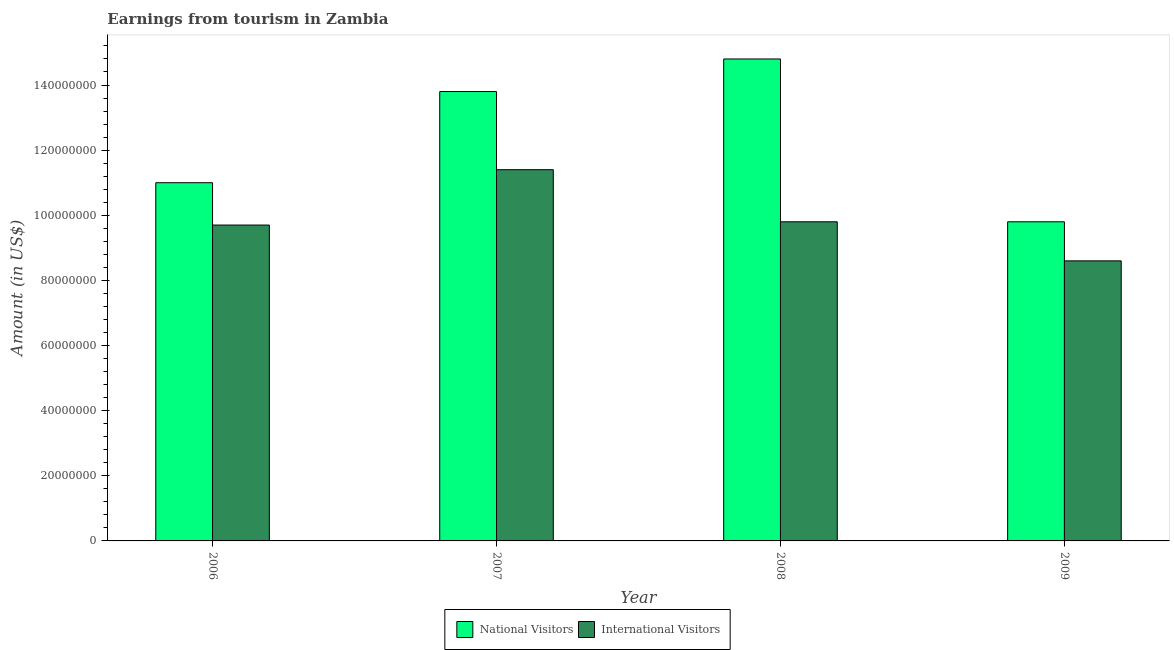How many different coloured bars are there?
Provide a short and direct response. 2. How many groups of bars are there?
Offer a terse response. 4. Are the number of bars on each tick of the X-axis equal?
Give a very brief answer. Yes. What is the amount earned from national visitors in 2008?
Your response must be concise. 1.48e+08. Across all years, what is the maximum amount earned from international visitors?
Ensure brevity in your answer.  1.14e+08. Across all years, what is the minimum amount earned from international visitors?
Your answer should be compact. 8.60e+07. In which year was the amount earned from international visitors maximum?
Your answer should be very brief. 2007. What is the total amount earned from national visitors in the graph?
Your answer should be compact. 4.94e+08. What is the difference between the amount earned from national visitors in 2006 and that in 2008?
Make the answer very short. -3.80e+07. What is the difference between the amount earned from international visitors in 2008 and the amount earned from national visitors in 2009?
Ensure brevity in your answer.  1.20e+07. What is the average amount earned from national visitors per year?
Provide a succinct answer. 1.24e+08. In the year 2008, what is the difference between the amount earned from national visitors and amount earned from international visitors?
Provide a short and direct response. 0. In how many years, is the amount earned from national visitors greater than 80000000 US$?
Your response must be concise. 4. What is the ratio of the amount earned from national visitors in 2006 to that in 2007?
Keep it short and to the point. 0.8. Is the difference between the amount earned from international visitors in 2006 and 2009 greater than the difference between the amount earned from national visitors in 2006 and 2009?
Give a very brief answer. No. What is the difference between the highest and the second highest amount earned from international visitors?
Ensure brevity in your answer.  1.60e+07. What is the difference between the highest and the lowest amount earned from national visitors?
Provide a succinct answer. 5.00e+07. What does the 1st bar from the left in 2008 represents?
Offer a terse response. National Visitors. What does the 1st bar from the right in 2007 represents?
Offer a terse response. International Visitors. Are all the bars in the graph horizontal?
Provide a succinct answer. No. What is the difference between two consecutive major ticks on the Y-axis?
Provide a short and direct response. 2.00e+07. Are the values on the major ticks of Y-axis written in scientific E-notation?
Offer a very short reply. No. Does the graph contain any zero values?
Keep it short and to the point. No. Does the graph contain grids?
Offer a very short reply. No. Where does the legend appear in the graph?
Keep it short and to the point. Bottom center. How are the legend labels stacked?
Make the answer very short. Horizontal. What is the title of the graph?
Offer a very short reply. Earnings from tourism in Zambia. What is the label or title of the Y-axis?
Provide a short and direct response. Amount (in US$). What is the Amount (in US$) in National Visitors in 2006?
Your answer should be very brief. 1.10e+08. What is the Amount (in US$) in International Visitors in 2006?
Offer a very short reply. 9.70e+07. What is the Amount (in US$) in National Visitors in 2007?
Provide a short and direct response. 1.38e+08. What is the Amount (in US$) of International Visitors in 2007?
Offer a very short reply. 1.14e+08. What is the Amount (in US$) in National Visitors in 2008?
Provide a short and direct response. 1.48e+08. What is the Amount (in US$) in International Visitors in 2008?
Ensure brevity in your answer.  9.80e+07. What is the Amount (in US$) in National Visitors in 2009?
Offer a terse response. 9.80e+07. What is the Amount (in US$) of International Visitors in 2009?
Provide a succinct answer. 8.60e+07. Across all years, what is the maximum Amount (in US$) of National Visitors?
Ensure brevity in your answer.  1.48e+08. Across all years, what is the maximum Amount (in US$) of International Visitors?
Provide a succinct answer. 1.14e+08. Across all years, what is the minimum Amount (in US$) in National Visitors?
Keep it short and to the point. 9.80e+07. Across all years, what is the minimum Amount (in US$) of International Visitors?
Provide a short and direct response. 8.60e+07. What is the total Amount (in US$) of National Visitors in the graph?
Provide a short and direct response. 4.94e+08. What is the total Amount (in US$) in International Visitors in the graph?
Your answer should be very brief. 3.95e+08. What is the difference between the Amount (in US$) of National Visitors in 2006 and that in 2007?
Give a very brief answer. -2.80e+07. What is the difference between the Amount (in US$) in International Visitors in 2006 and that in 2007?
Give a very brief answer. -1.70e+07. What is the difference between the Amount (in US$) of National Visitors in 2006 and that in 2008?
Offer a very short reply. -3.80e+07. What is the difference between the Amount (in US$) of National Visitors in 2006 and that in 2009?
Ensure brevity in your answer.  1.20e+07. What is the difference between the Amount (in US$) in International Visitors in 2006 and that in 2009?
Provide a short and direct response. 1.10e+07. What is the difference between the Amount (in US$) in National Visitors in 2007 and that in 2008?
Give a very brief answer. -1.00e+07. What is the difference between the Amount (in US$) in International Visitors in 2007 and that in 2008?
Provide a short and direct response. 1.60e+07. What is the difference between the Amount (in US$) in National Visitors in 2007 and that in 2009?
Make the answer very short. 4.00e+07. What is the difference between the Amount (in US$) of International Visitors in 2007 and that in 2009?
Your answer should be very brief. 2.80e+07. What is the difference between the Amount (in US$) in National Visitors in 2006 and the Amount (in US$) in International Visitors in 2008?
Offer a very short reply. 1.20e+07. What is the difference between the Amount (in US$) in National Visitors in 2006 and the Amount (in US$) in International Visitors in 2009?
Your answer should be very brief. 2.40e+07. What is the difference between the Amount (in US$) of National Visitors in 2007 and the Amount (in US$) of International Visitors in 2008?
Ensure brevity in your answer.  4.00e+07. What is the difference between the Amount (in US$) of National Visitors in 2007 and the Amount (in US$) of International Visitors in 2009?
Offer a very short reply. 5.20e+07. What is the difference between the Amount (in US$) of National Visitors in 2008 and the Amount (in US$) of International Visitors in 2009?
Provide a succinct answer. 6.20e+07. What is the average Amount (in US$) of National Visitors per year?
Offer a terse response. 1.24e+08. What is the average Amount (in US$) in International Visitors per year?
Your answer should be compact. 9.88e+07. In the year 2006, what is the difference between the Amount (in US$) in National Visitors and Amount (in US$) in International Visitors?
Offer a very short reply. 1.30e+07. In the year 2007, what is the difference between the Amount (in US$) in National Visitors and Amount (in US$) in International Visitors?
Keep it short and to the point. 2.40e+07. In the year 2008, what is the difference between the Amount (in US$) in National Visitors and Amount (in US$) in International Visitors?
Offer a very short reply. 5.00e+07. In the year 2009, what is the difference between the Amount (in US$) in National Visitors and Amount (in US$) in International Visitors?
Your answer should be compact. 1.20e+07. What is the ratio of the Amount (in US$) of National Visitors in 2006 to that in 2007?
Provide a succinct answer. 0.8. What is the ratio of the Amount (in US$) in International Visitors in 2006 to that in 2007?
Your answer should be very brief. 0.85. What is the ratio of the Amount (in US$) of National Visitors in 2006 to that in 2008?
Offer a very short reply. 0.74. What is the ratio of the Amount (in US$) of National Visitors in 2006 to that in 2009?
Your answer should be compact. 1.12. What is the ratio of the Amount (in US$) of International Visitors in 2006 to that in 2009?
Make the answer very short. 1.13. What is the ratio of the Amount (in US$) in National Visitors in 2007 to that in 2008?
Offer a very short reply. 0.93. What is the ratio of the Amount (in US$) in International Visitors in 2007 to that in 2008?
Your response must be concise. 1.16. What is the ratio of the Amount (in US$) in National Visitors in 2007 to that in 2009?
Offer a terse response. 1.41. What is the ratio of the Amount (in US$) of International Visitors in 2007 to that in 2009?
Provide a succinct answer. 1.33. What is the ratio of the Amount (in US$) of National Visitors in 2008 to that in 2009?
Make the answer very short. 1.51. What is the ratio of the Amount (in US$) in International Visitors in 2008 to that in 2009?
Give a very brief answer. 1.14. What is the difference between the highest and the second highest Amount (in US$) of International Visitors?
Your answer should be compact. 1.60e+07. What is the difference between the highest and the lowest Amount (in US$) of International Visitors?
Make the answer very short. 2.80e+07. 